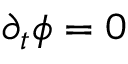Convert formula to latex. <formula><loc_0><loc_0><loc_500><loc_500>\partial _ { t } \phi = 0</formula> 